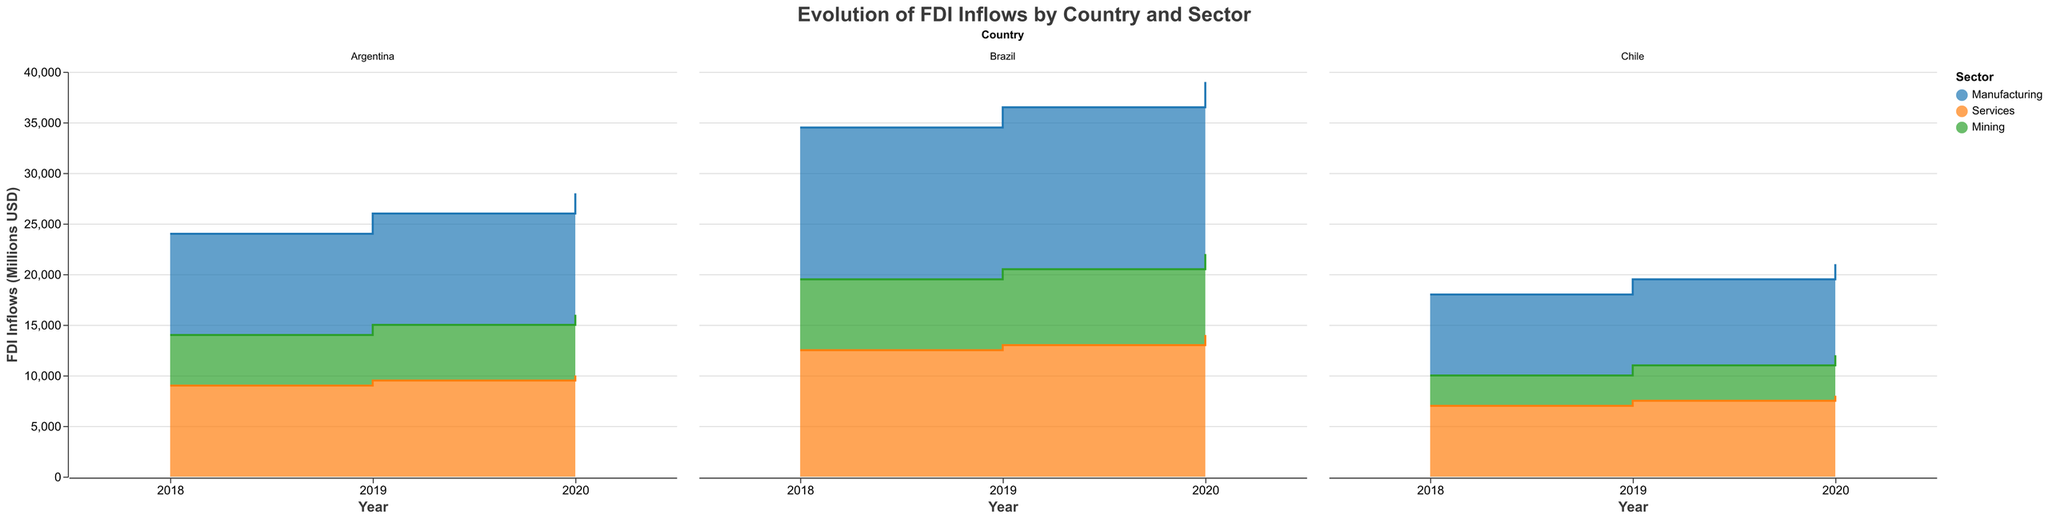What is the title of the figure? The title of the figure is located at the top and provides a summary of the information depicted. It reads "Evolution of FDI Inflows by Country and Sector".
Answer: Evolution of FDI Inflows by Country and Sector How many countries are included in the figure? The figure uses faceting to show data from different countries. There are three facets named "Brazil", "Argentina", and "Chile".
Answer: 3 Which sector had the highest FDI inflows in Brazil in 2020? To find this, locate Brazil's facet and the year 2020. Compare the step areas for Manufacturing, Services, and Mining. The highest inflow is for Manufacturing.
Answer: Manufacturing What is the overall trend in FDI inflows for the Services sector in Argentina from 2018 to 2020? Observe the step area in Argentina's facet for the Services sector from 2018 to 2020. Note the change in height: from 9000 in 2018, to 9500 in 2019, and to 10000 in 2020, showing a consistent increase.
Answer: Increasing By how much did the Manufacturing sector's FDI inflows increase in Chile from 2018 to 2020? Locate the Manufacturing sector in Chile’s facet from 2018 to 2020. The FDI inflows go from 8000 in 2018 to 9000 in 2020, an increase of 1000.
Answer: 1000 Which country experienced the smallest increase in FDI inflows for the Mining sector between 2018 and 2020? Compare the step areas for the Mining sector across all three countries. For Brazil, the increase is from 7000 to 8000 (1000); for Argentina, it is from 5000 to 6000 (1000); and for Chile, it is from 3000 to 4000 (1000). All increases are equal. It’s a tie.
Answer: All equal Comparing 2018 to 2019, which country saw the highest absolute change in FDI inflows in the Mining sector? Evaluate the changes in the Mining sector from 2018 to 2019 for each country. Brazil increased from 7000 to 7500 (500); Argentina increased from 5000 to 5500 (500); Chile increased from 3000 to 3500 (500). All changes are equal.
Answer: All equal What is the sum of FDI inflows for all sectors in Argentina in 2020? Add the FDI inflows for all sectors in Argentina in 2020: Manufacturing (12000) + Services (10000) + Mining (6000) = 28000.
Answer: 28000 Which sector in Brazil has a consistent increase in FDI inflows each year from 2018 to 2020? Look at the faceted chart for Brazil and track each sector from 2018 to 2020. Manufacturing shows consistent increases: 15000 to 16000 to 17000.
Answer: Manufacturing 